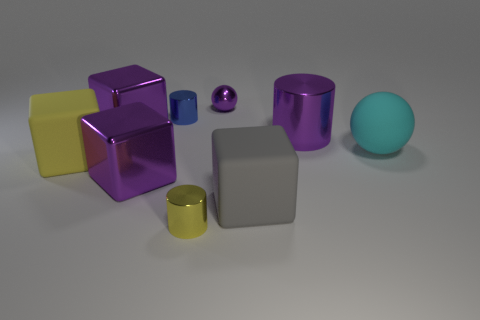What might be the purpose of these objects? These objects could serve multiple purposes. Given their simple geometric shapes and uniform colors, they may be part of a visual study exploring light, shadow, reflection, and texture. Alternatively, they could be design elements for an educational tool, teaching about shapes, volume, or even color theory. 